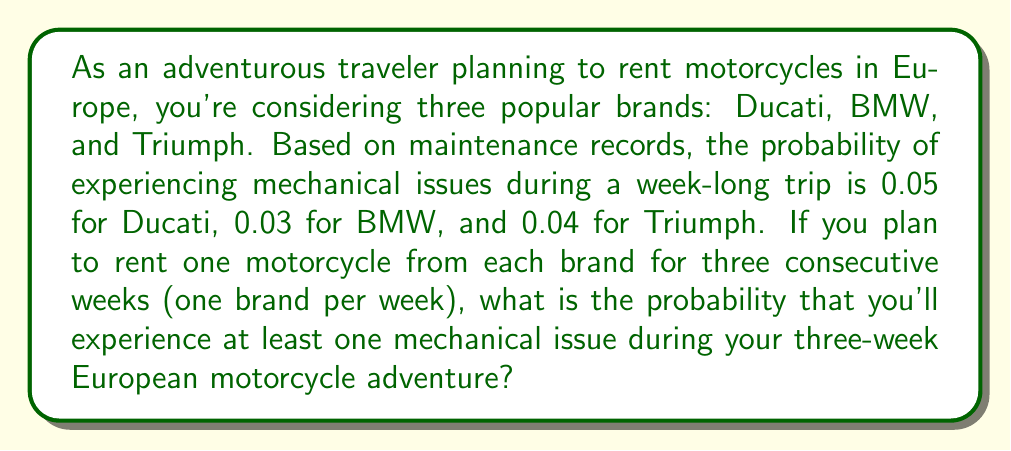Give your solution to this math problem. To solve this problem, we'll use the complement rule of probability. Let's break it down step-by-step:

1) First, let's calculate the probability of not experiencing any mechanical issues for each brand:

   Ducati: $1 - 0.05 = 0.95$
   BMW: $1 - 0.03 = 0.97$
   Triumph: $1 - 0.04 = 0.96$

2) The probability of not experiencing any mechanical issues during the entire three-week trip is the product of these probabilities:

   $P(\text{no issues}) = 0.95 \times 0.97 \times 0.96 = 0.8836$

3) Now, we can use the complement rule to find the probability of experiencing at least one mechanical issue:

   $P(\text{at least one issue}) = 1 - P(\text{no issues})$

4) Substituting the value we calculated:

   $P(\text{at least one issue}) = 1 - 0.8836 = 0.1164$

Therefore, the probability of experiencing at least one mechanical issue during the three-week trip is approximately 0.1164 or 11.64%.
Answer: The probability of experiencing at least one mechanical issue during the three-week European motorcycle adventure is approximately $0.1164$ or $11.64\%$. 